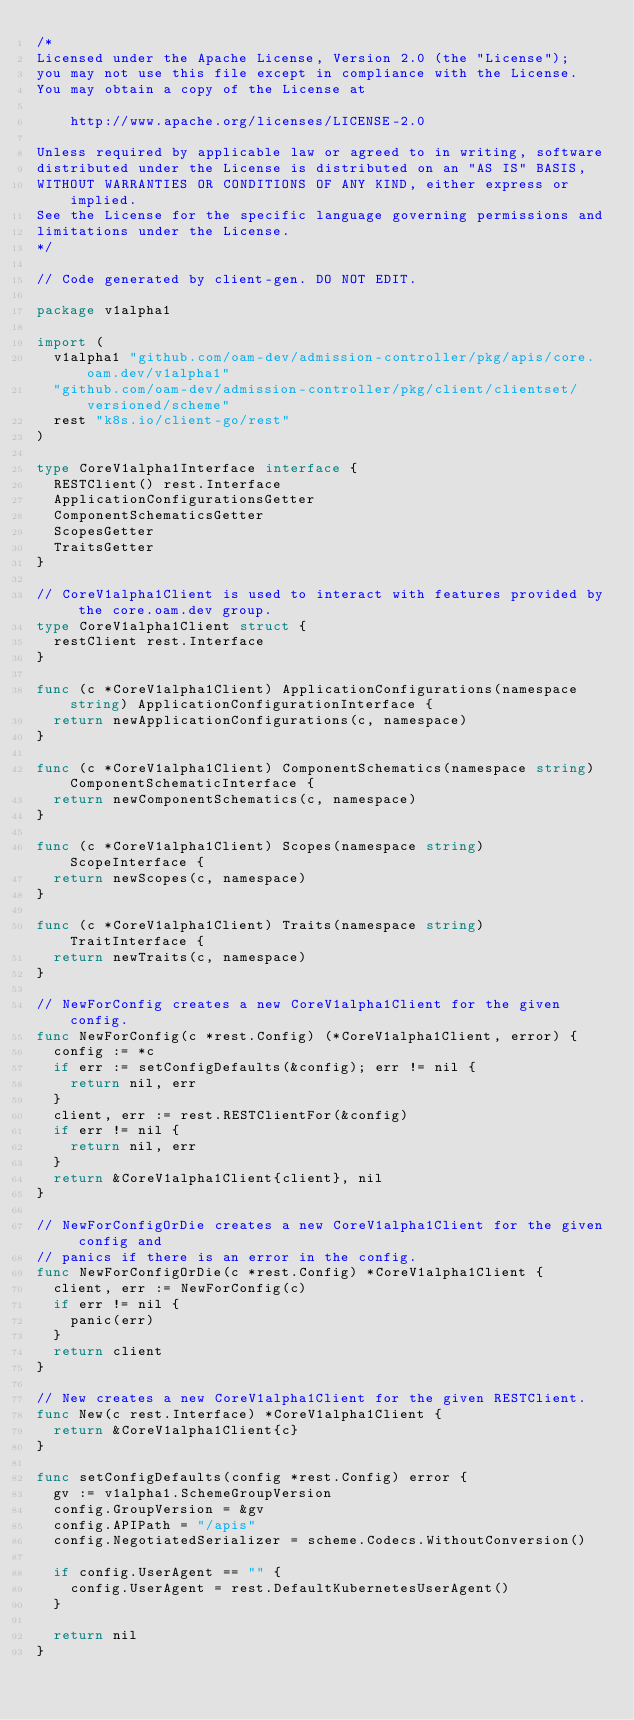Convert code to text. <code><loc_0><loc_0><loc_500><loc_500><_Go_>/*
Licensed under the Apache License, Version 2.0 (the "License");
you may not use this file except in compliance with the License.
You may obtain a copy of the License at

    http://www.apache.org/licenses/LICENSE-2.0

Unless required by applicable law or agreed to in writing, software
distributed under the License is distributed on an "AS IS" BASIS,
WITHOUT WARRANTIES OR CONDITIONS OF ANY KIND, either express or implied.
See the License for the specific language governing permissions and
limitations under the License.
*/

// Code generated by client-gen. DO NOT EDIT.

package v1alpha1

import (
	v1alpha1 "github.com/oam-dev/admission-controller/pkg/apis/core.oam.dev/v1alpha1"
	"github.com/oam-dev/admission-controller/pkg/client/clientset/versioned/scheme"
	rest "k8s.io/client-go/rest"
)

type CoreV1alpha1Interface interface {
	RESTClient() rest.Interface
	ApplicationConfigurationsGetter
	ComponentSchematicsGetter
	ScopesGetter
	TraitsGetter
}

// CoreV1alpha1Client is used to interact with features provided by the core.oam.dev group.
type CoreV1alpha1Client struct {
	restClient rest.Interface
}

func (c *CoreV1alpha1Client) ApplicationConfigurations(namespace string) ApplicationConfigurationInterface {
	return newApplicationConfigurations(c, namespace)
}

func (c *CoreV1alpha1Client) ComponentSchematics(namespace string) ComponentSchematicInterface {
	return newComponentSchematics(c, namespace)
}

func (c *CoreV1alpha1Client) Scopes(namespace string) ScopeInterface {
	return newScopes(c, namespace)
}

func (c *CoreV1alpha1Client) Traits(namespace string) TraitInterface {
	return newTraits(c, namespace)
}

// NewForConfig creates a new CoreV1alpha1Client for the given config.
func NewForConfig(c *rest.Config) (*CoreV1alpha1Client, error) {
	config := *c
	if err := setConfigDefaults(&config); err != nil {
		return nil, err
	}
	client, err := rest.RESTClientFor(&config)
	if err != nil {
		return nil, err
	}
	return &CoreV1alpha1Client{client}, nil
}

// NewForConfigOrDie creates a new CoreV1alpha1Client for the given config and
// panics if there is an error in the config.
func NewForConfigOrDie(c *rest.Config) *CoreV1alpha1Client {
	client, err := NewForConfig(c)
	if err != nil {
		panic(err)
	}
	return client
}

// New creates a new CoreV1alpha1Client for the given RESTClient.
func New(c rest.Interface) *CoreV1alpha1Client {
	return &CoreV1alpha1Client{c}
}

func setConfigDefaults(config *rest.Config) error {
	gv := v1alpha1.SchemeGroupVersion
	config.GroupVersion = &gv
	config.APIPath = "/apis"
	config.NegotiatedSerializer = scheme.Codecs.WithoutConversion()

	if config.UserAgent == "" {
		config.UserAgent = rest.DefaultKubernetesUserAgent()
	}

	return nil
}
</code> 